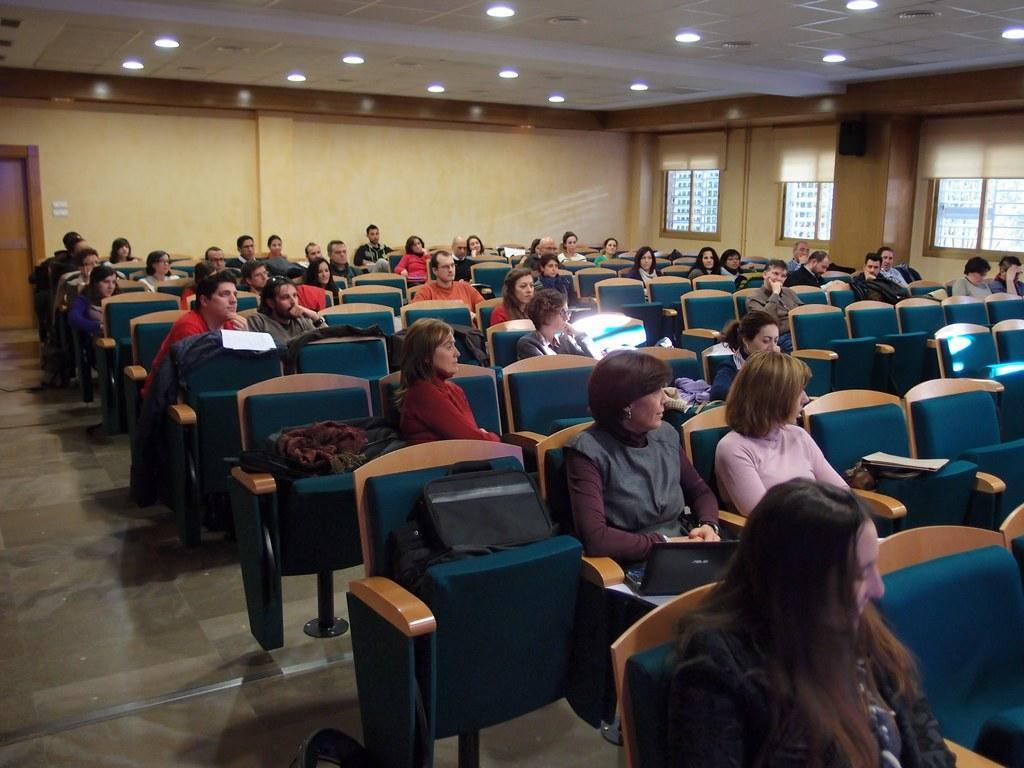How would you summarize this image in a sentence or two? At the top we can see ceiling and lights. On the right side of the picture we can see windows and through glass buildings are visible. We can see people sitting on the chairs. In the top left corner we can see a door. At the bottom there is a floor. 